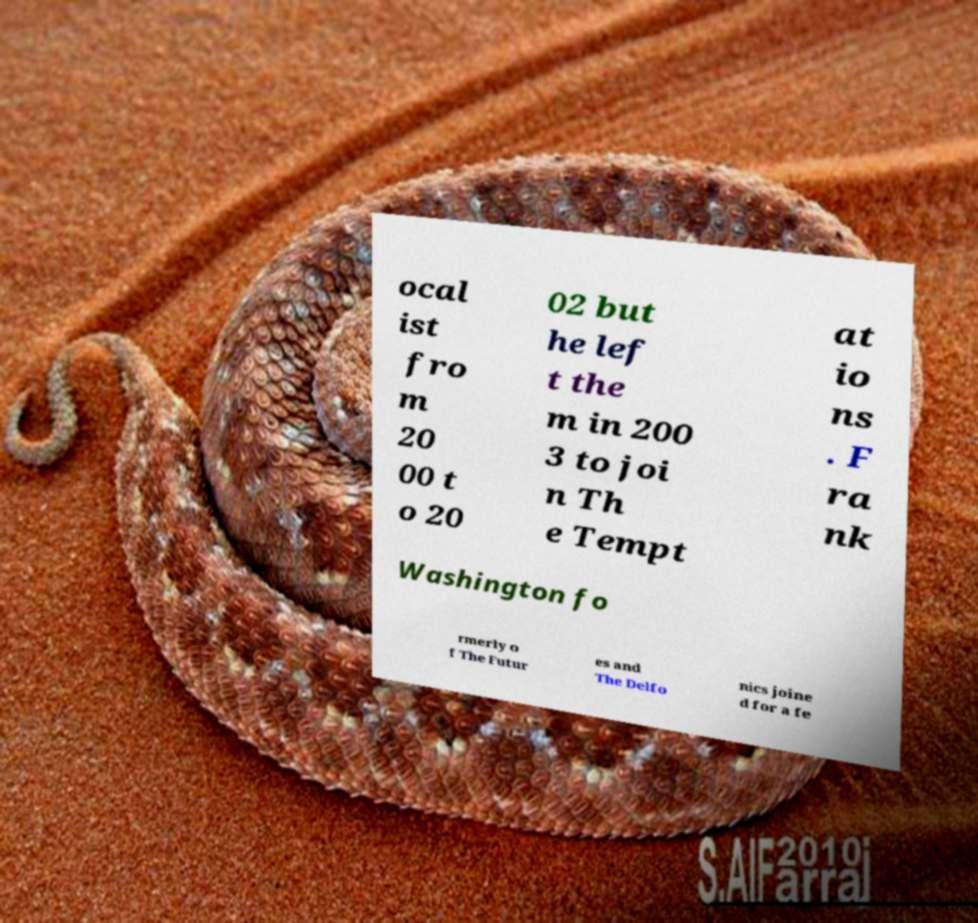Please read and relay the text visible in this image. What does it say? ocal ist fro m 20 00 t o 20 02 but he lef t the m in 200 3 to joi n Th e Tempt at io ns . F ra nk Washington fo rmerly o f The Futur es and The Delfo nics joine d for a fe 